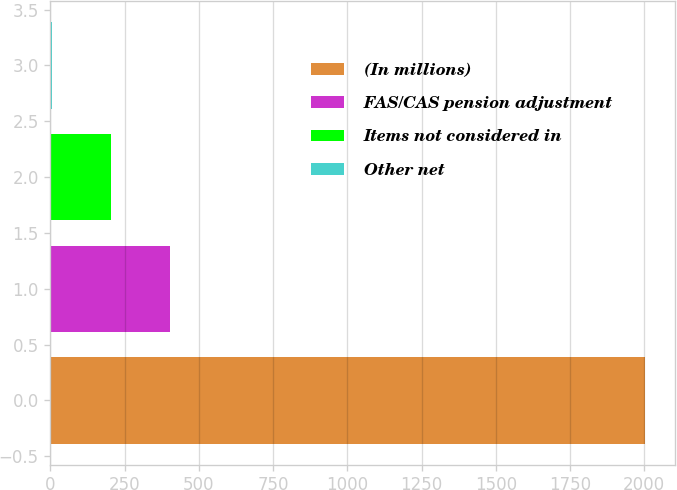<chart> <loc_0><loc_0><loc_500><loc_500><bar_chart><fcel>(In millions)<fcel>FAS/CAS pension adjustment<fcel>Items not considered in<fcel>Other net<nl><fcel>2003<fcel>403.8<fcel>203.9<fcel>4<nl></chart> 